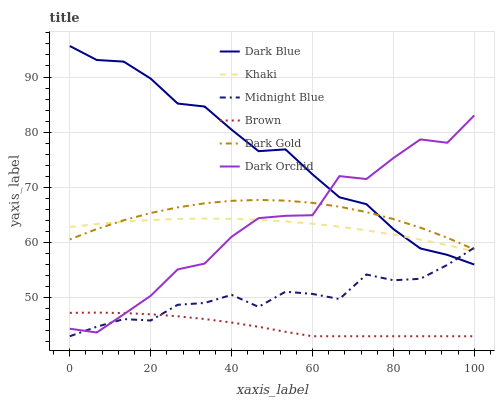Does Brown have the minimum area under the curve?
Answer yes or no. Yes. Does Dark Blue have the maximum area under the curve?
Answer yes or no. Yes. Does Khaki have the minimum area under the curve?
Answer yes or no. No. Does Khaki have the maximum area under the curve?
Answer yes or no. No. Is Khaki the smoothest?
Answer yes or no. Yes. Is Dark Orchid the roughest?
Answer yes or no. Yes. Is Midnight Blue the smoothest?
Answer yes or no. No. Is Midnight Blue the roughest?
Answer yes or no. No. Does Brown have the lowest value?
Answer yes or no. Yes. Does Khaki have the lowest value?
Answer yes or no. No. Does Dark Blue have the highest value?
Answer yes or no. Yes. Does Khaki have the highest value?
Answer yes or no. No. Is Brown less than Dark Gold?
Answer yes or no. Yes. Is Khaki greater than Brown?
Answer yes or no. Yes. Does Midnight Blue intersect Dark Orchid?
Answer yes or no. Yes. Is Midnight Blue less than Dark Orchid?
Answer yes or no. No. Is Midnight Blue greater than Dark Orchid?
Answer yes or no. No. Does Brown intersect Dark Gold?
Answer yes or no. No. 